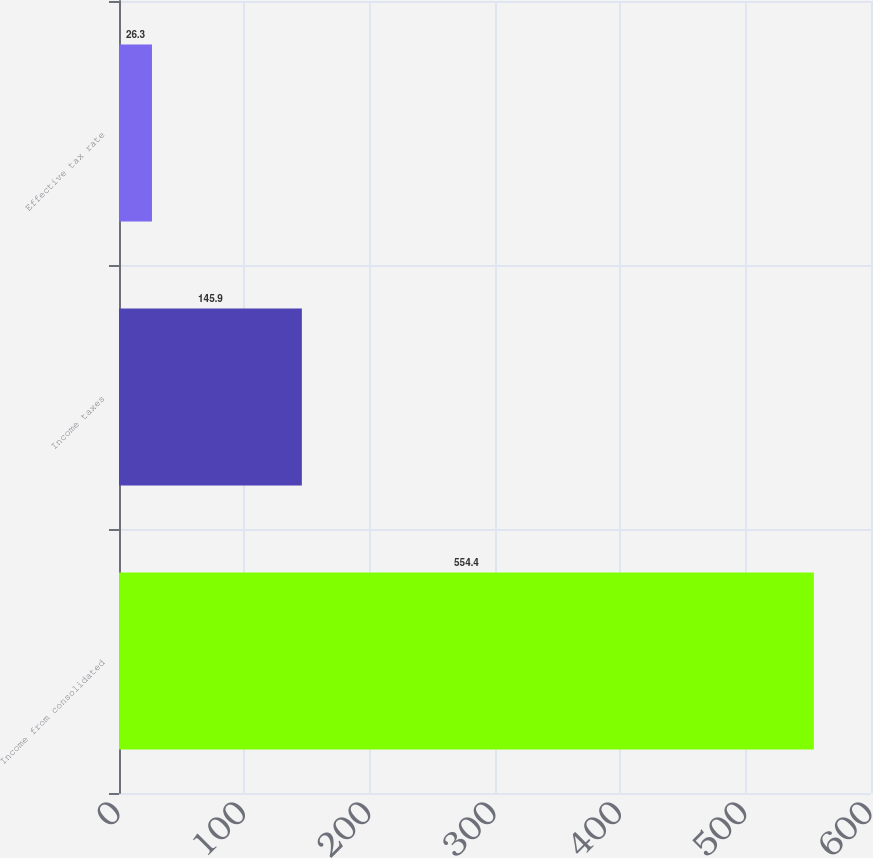Convert chart. <chart><loc_0><loc_0><loc_500><loc_500><bar_chart><fcel>Income from consolidated<fcel>Income taxes<fcel>Effective tax rate<nl><fcel>554.4<fcel>145.9<fcel>26.3<nl></chart> 